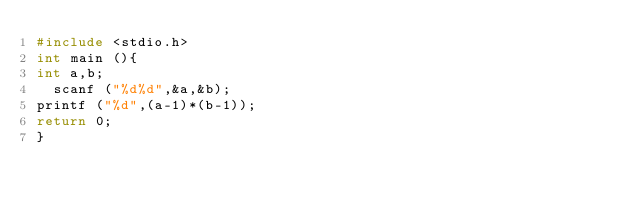<code> <loc_0><loc_0><loc_500><loc_500><_C_>#include <stdio.h>
int main (){
int a,b;
  scanf ("%d%d",&a,&b);
printf ("%d",(a-1)*(b-1));
return 0;
}</code> 